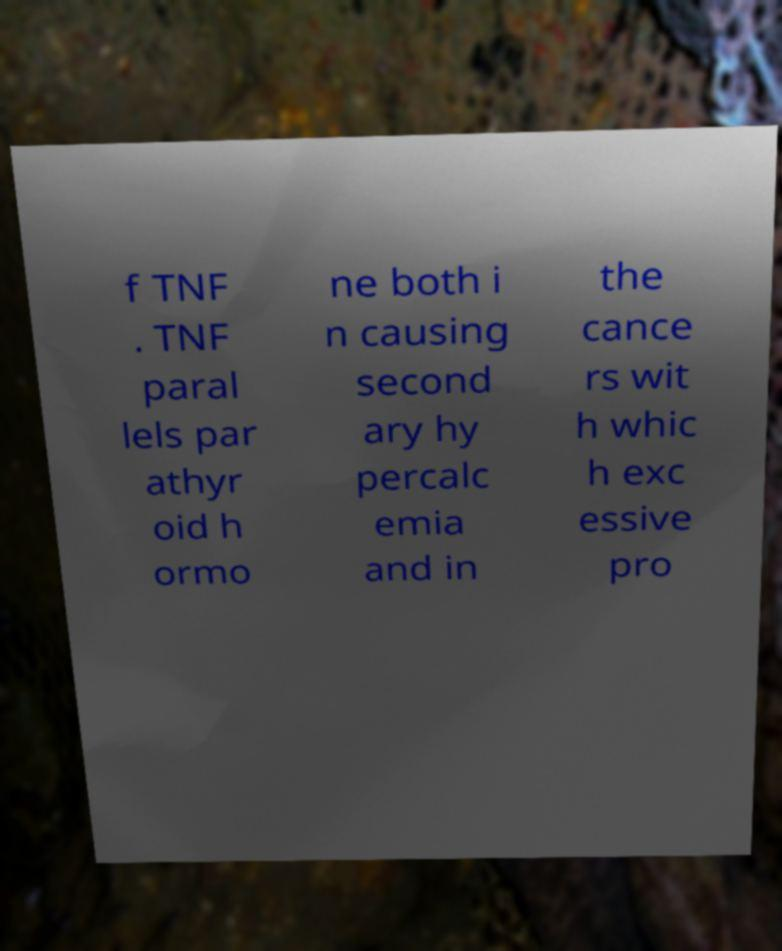Please identify and transcribe the text found in this image. f TNF . TNF paral lels par athyr oid h ormo ne both i n causing second ary hy percalc emia and in the cance rs wit h whic h exc essive pro 